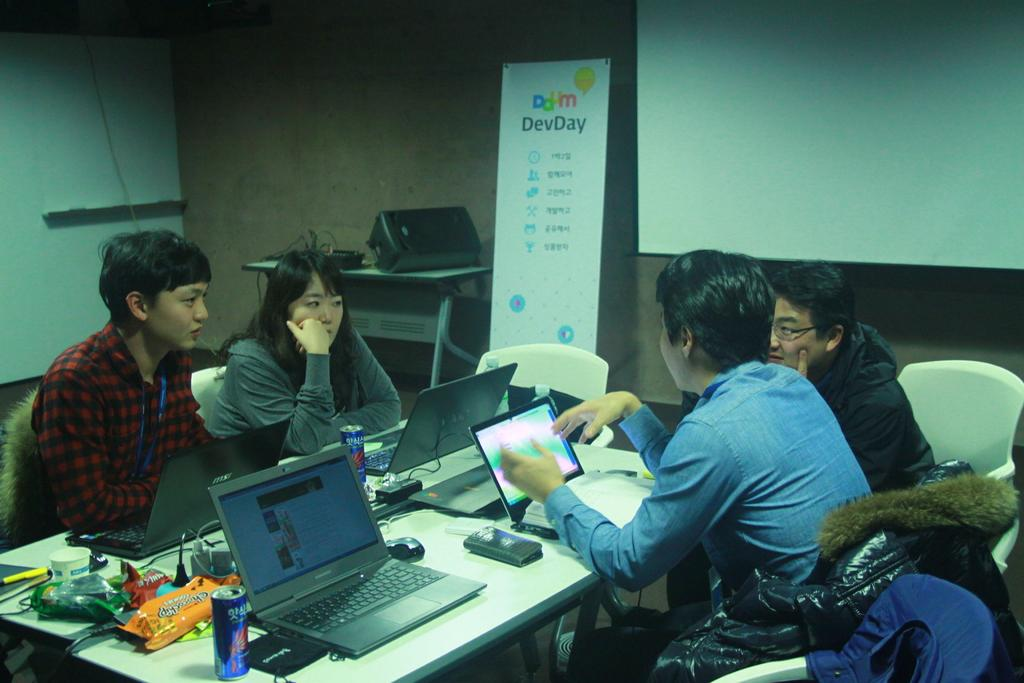<image>
Create a compact narrative representing the image presented. Four people have a conversation in front of a sign that says DevDay. 